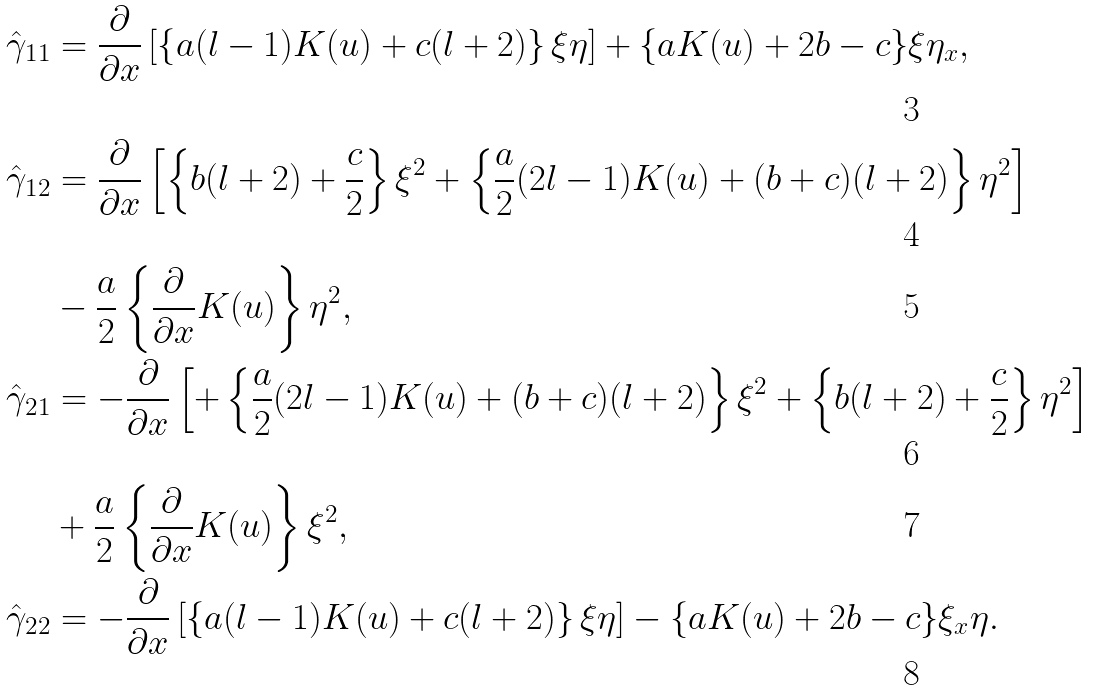<formula> <loc_0><loc_0><loc_500><loc_500>\hat { \gamma } _ { 1 1 } & = \frac { \partial } { \partial x } \left [ \left \{ a ( l - 1 ) K ( u ) + c ( l + 2 ) \right \} \xi \eta \right ] + \{ a K ( u ) + 2 b - c \} \xi \eta _ { x } , \\ \hat { \gamma } _ { 1 2 } & = \frac { \partial } { \partial x } \left [ \left \{ b ( l + 2 ) + \frac { c } { 2 } \right \} \xi ^ { 2 } + \left \{ \frac { a } { 2 } ( 2 l - 1 ) K ( u ) + ( b + c ) ( l + 2 ) \right \} \eta ^ { 2 } \right ] \\ & - \frac { a } { 2 } \left \{ \frac { \partial } { \partial x } K ( u ) \right \} \eta ^ { 2 } , \\ \hat { \gamma } _ { 2 1 } & = - \frac { \partial } { \partial x } \left [ + \left \{ \frac { a } { 2 } ( 2 l - 1 ) K ( u ) + ( b + c ) ( l + 2 ) \right \} \xi ^ { 2 } + \left \{ b ( l + 2 ) + \frac { c } { 2 } \right \} \eta ^ { 2 } \right ] \\ & + \frac { a } { 2 } \left \{ \frac { \partial } { \partial x } K ( u ) \right \} \xi ^ { 2 } , \\ \hat { \gamma } _ { 2 2 } & = - \frac { \partial } { \partial x } \left [ \left \{ a ( l - 1 ) K ( u ) + c ( l + 2 ) \right \} \xi \eta \right ] - \{ a K ( u ) + 2 b - c \} \xi _ { x } \eta .</formula> 